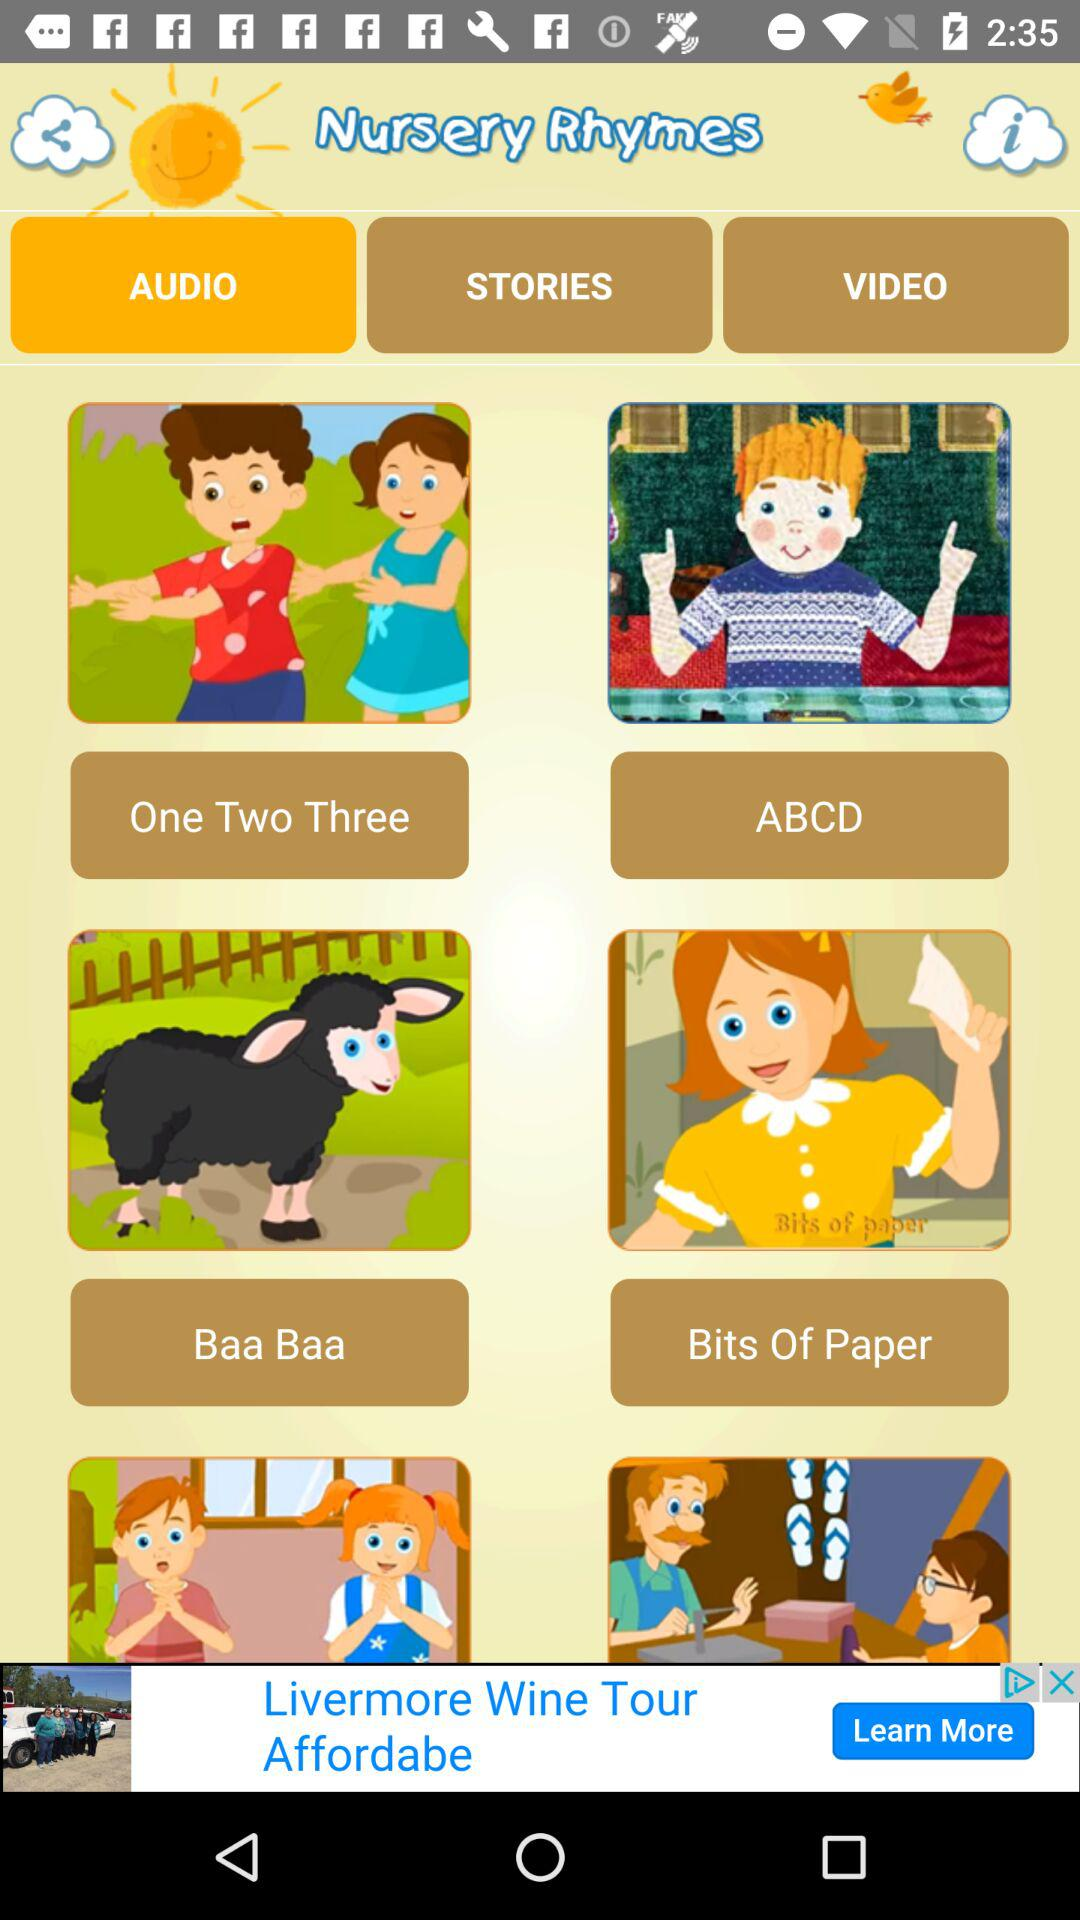What option is selected for the "Nursery Rhymes"? The selected option is "AUDIO". 